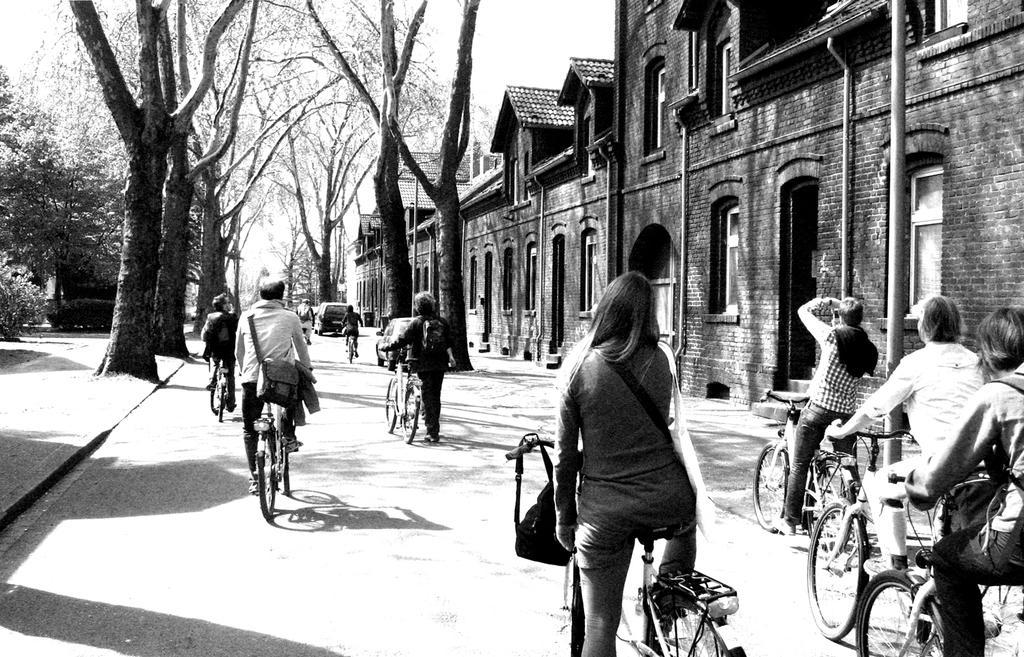How would you summarize this image in a sentence or two? Here these people are riding bicycles on a road. A woman is standing on a bicycle right side there is a building. Beside there are trees It's a sky. 